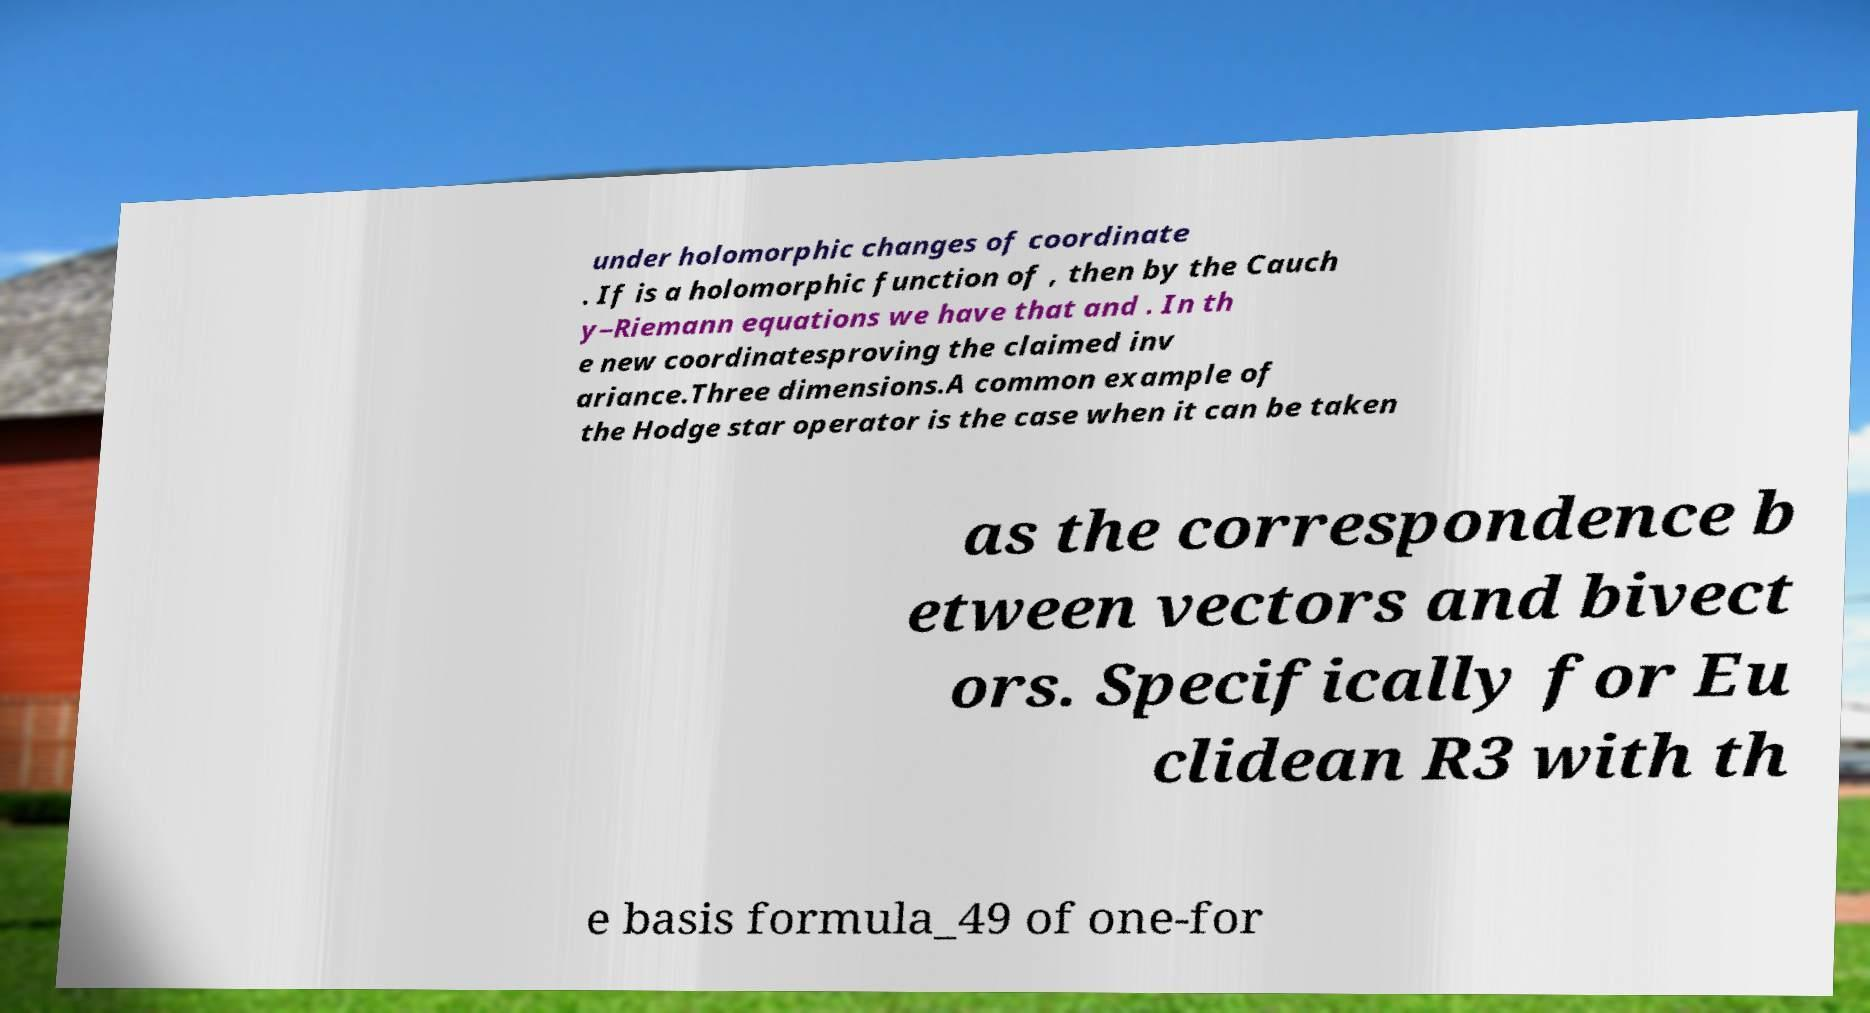Could you assist in decoding the text presented in this image and type it out clearly? under holomorphic changes of coordinate . If is a holomorphic function of , then by the Cauch y–Riemann equations we have that and . In th e new coordinatesproving the claimed inv ariance.Three dimensions.A common example of the Hodge star operator is the case when it can be taken as the correspondence b etween vectors and bivect ors. Specifically for Eu clidean R3 with th e basis formula_49 of one-for 